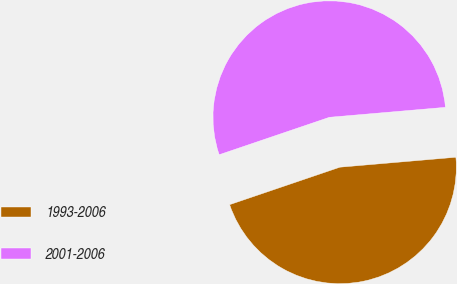Convert chart to OTSL. <chart><loc_0><loc_0><loc_500><loc_500><pie_chart><fcel>1993-2006<fcel>2001-2006<nl><fcel>46.15%<fcel>53.85%<nl></chart> 